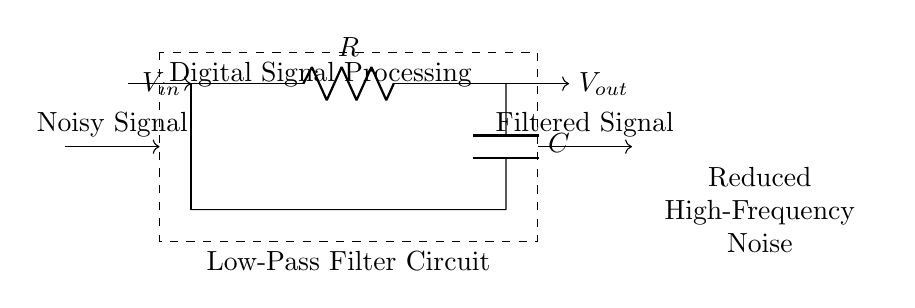What components are used in this circuit? The circuit contains a resistor and a capacitor, which are the basic components for a low-pass filter. These components are drawn in the circuit diagram, indicating their roles in filtering high-frequency signals.
Answer: resistor and capacitor What is the function of this circuit? The primary function of this circuit is to reduce high-frequency noise from a noisy signal while allowing low-frequency signals to pass through, serving as a low-pass filter. This is evident from the title in the diagram and the connections depicted.
Answer: noise reduction What is the input signal labeled in the diagram? The input signal in the circuit is labeled as V sub in, which represents the voltage of the noisy signal that is to be filtered. This is marked by an arrow pointing towards the first connection in the diagram.
Answer: V sub in What type of filter is this circuit? The circuit is identified as a low-pass filter because of its ability to allow low frequencies to pass while attenuating frequencies above a certain cutoff. This classification is confirmed by the name on the drawing and its configuration.
Answer: low-pass filter What is the output voltage labeled in the diagram? The output voltage from the circuit is labeled as V sub out, which signifies the filtered signal after the noise reduction process has occurred. This is indicated by an arrow leading away from the last component in the circuit.
Answer: V sub out How many connections does the capacitor have in this circuit? The capacitor in this circuit has two connections: one connected to the resistor and the other connected to the ground, completing the circuit path. This can be seen in the diagram where the capacitor bridges these two points.
Answer: two connections What does the dashed rectangle signify in the circuit diagram? The dashed rectangle in the diagram signifies the overall system or module of digital signal processing, encapsulating the low-pass filter circuit and indicating that this is part of a larger process. This area is labeled accordingly to suggest its function.
Answer: digital signal processing 